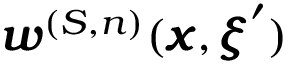<formula> <loc_0><loc_0><loc_500><loc_500>{ \pm b w } ^ { ( S , n ) } ( { \pm b x } , { \pm b \xi } ^ { \prime } )</formula> 